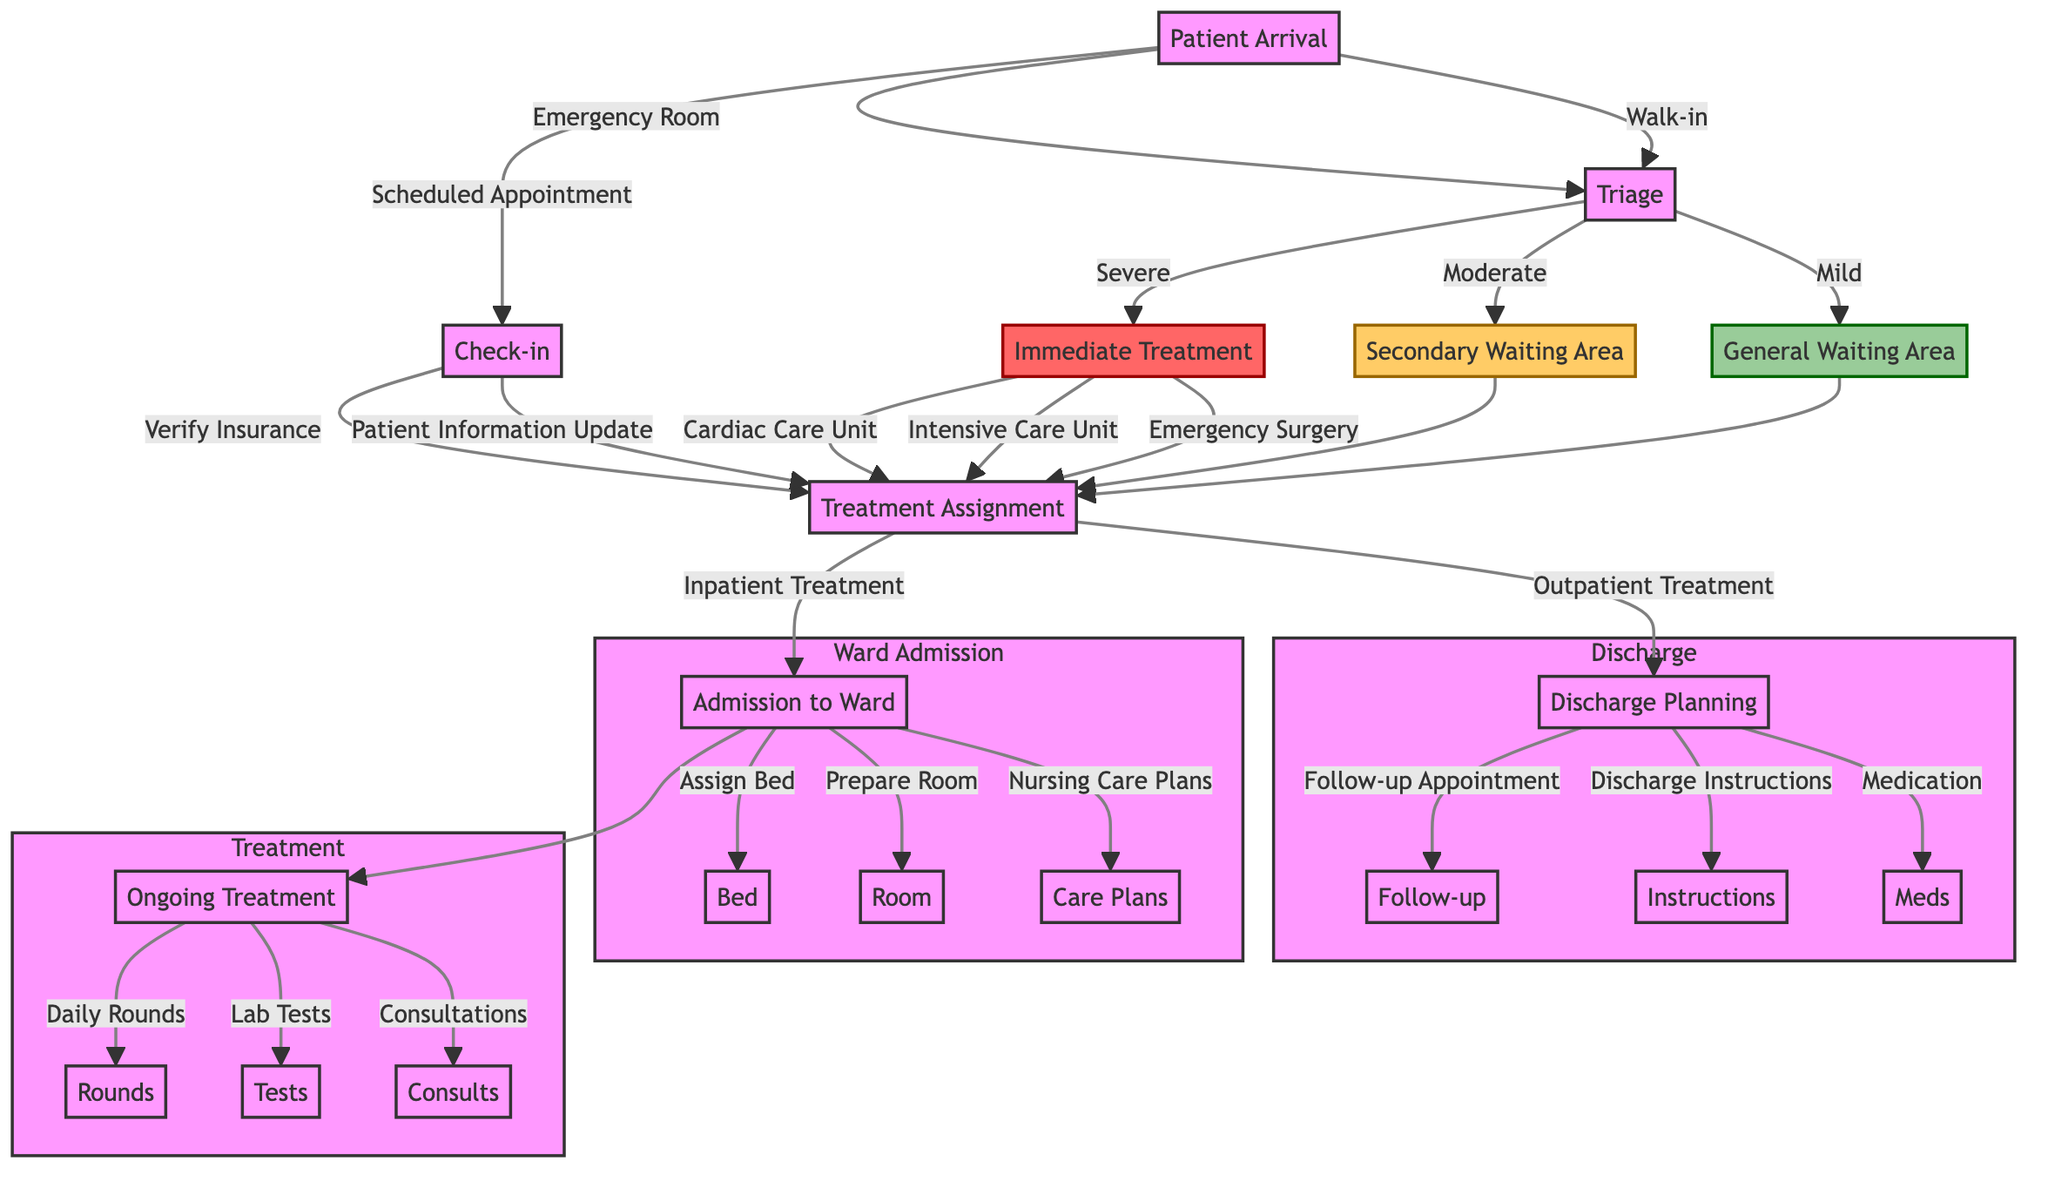What are the initial steps after patient arrival? The diagram shows three initial steps after patient arrival: Emergency Room, Scheduled Appointment, and Walk-in. Each leads to different next steps.
Answer: Emergency Room, Scheduled Appointment, Walk-in How many types of triage categories are there? The diagram indicates three triage categories: Severe, Moderate, and Mild.
Answer: Three What happens to patients categorized as Severe during triage? Patients categorized as Severe proceed to Immediate Treatment, which is the next step after triage.
Answer: Immediate Treatment What is the next step for patients who have Outpatient Treatment? Following Outpatient Treatment, the next step is Discharge Planning.
Answer: Discharge Planning What elements are involved in the Admission to Ward process? The diagram outlines three elements involved in the Admission to Ward: Assign Bed, Prepare Room, and Nursing Care Plans.
Answer: Assign Bed, Prepare Room, Nursing Care Plans If a patient is in the Secondary Waiting Area, what are their next actions? From the Secondary Waiting Area, patients will move to the Treatment Assignment step where they will decide between Outpatient Treatment or Inpatient Treatment.
Answer: Treatment Assignment What is the relationship between Triage and Patient Check-in? Triage and Patient Check-in are both processes that stem from Patient Arrival. Triage is followed by Immediate Treatment, while Check-in leads directly to Treatment Assignment.
Answer: Both stem from Patient Arrival Explain the flow for a patient who walks in for care. A patient who walks in arrives at the Emergency Room and goes to Triage. Based on the triage outcome (Severe, Moderate, or Mild), they will be directed towards Immediate Treatment, Secondary Waiting Area, or General Waiting Area, respectively.
Answer: Triage, then based on severity: Immediate Treatment, Secondary Waiting Area, or General Waiting Area 